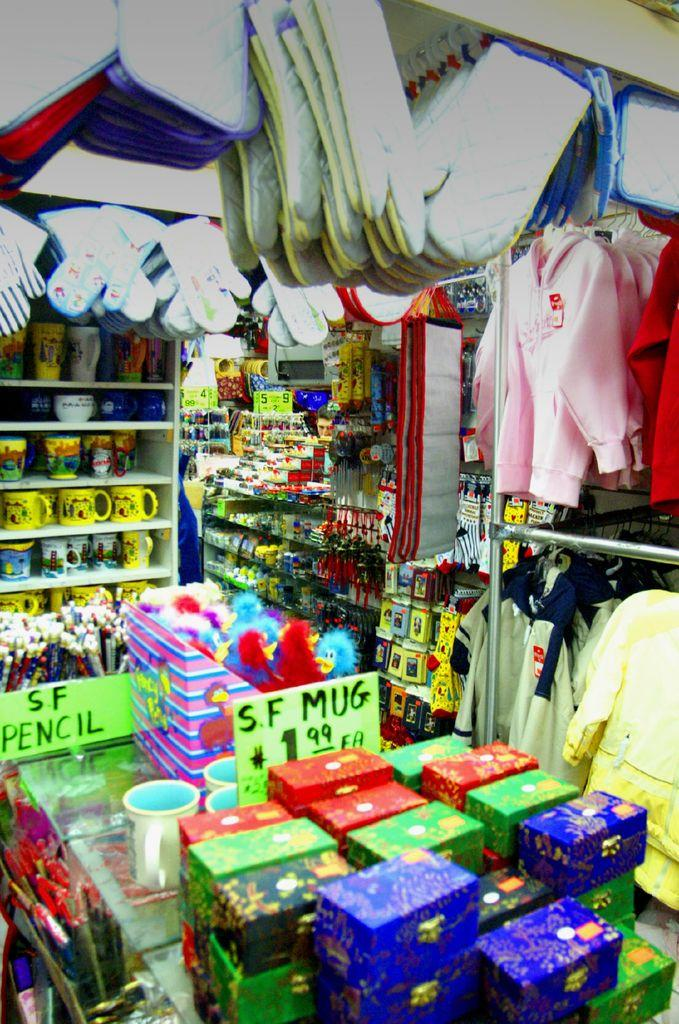<image>
Write a terse but informative summary of the picture. Store selling clothes and other items with a sign that says "SF MUG" is $1.99. 